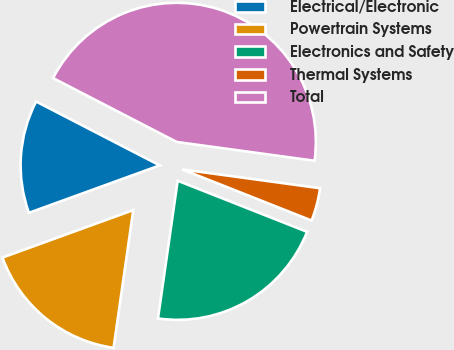<chart> <loc_0><loc_0><loc_500><loc_500><pie_chart><fcel>Electrical/Electronic<fcel>Powertrain Systems<fcel>Electronics and Safety<fcel>Thermal Systems<fcel>Total<nl><fcel>13.13%<fcel>17.2%<fcel>21.27%<fcel>3.83%<fcel>44.57%<nl></chart> 